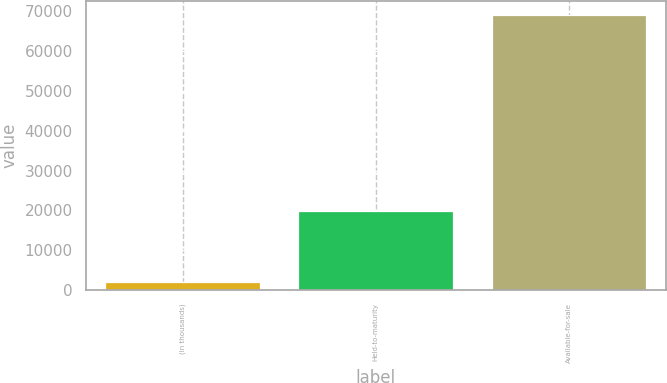Convert chart to OTSL. <chart><loc_0><loc_0><loc_500><loc_500><bar_chart><fcel>(In thousands)<fcel>Held-to-maturity<fcel>Available-for-sale<nl><fcel>2013<fcel>19905<fcel>69061<nl></chart> 